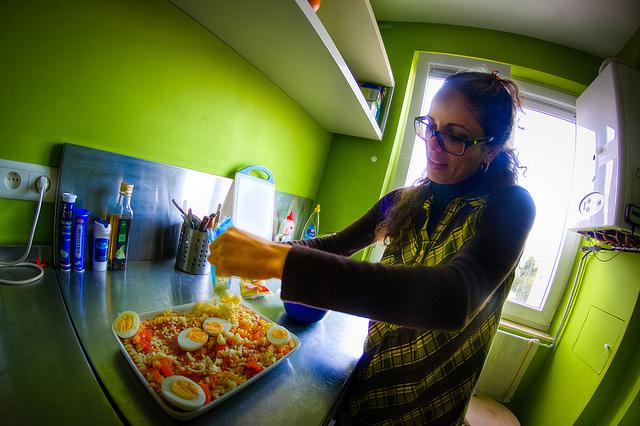What dish is being made?
Write a very short answer. Salad. What is the color of the label of the third bottle?
Concise answer only. Blue. What type of meal is she preparing?
Short answer required. Casserole. Does the lady have long hair?
Concise answer only. Yes. Who is making the dish?
Be succinct. Woman. 